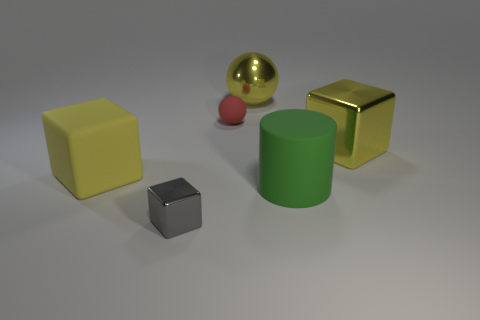Subtract all big cubes. How many cubes are left? 1 Subtract 2 blocks. How many blocks are left? 1 Subtract all yellow balls. How many balls are left? 1 Add 1 red objects. How many objects exist? 7 Subtract all yellow cubes. How many yellow balls are left? 1 Subtract all yellow cylinders. Subtract all yellow cubes. How many cylinders are left? 1 Add 3 large cyan rubber things. How many large cyan rubber things exist? 3 Subtract 0 red cylinders. How many objects are left? 6 Subtract all balls. How many objects are left? 4 Subtract all small green objects. Subtract all large yellow rubber blocks. How many objects are left? 5 